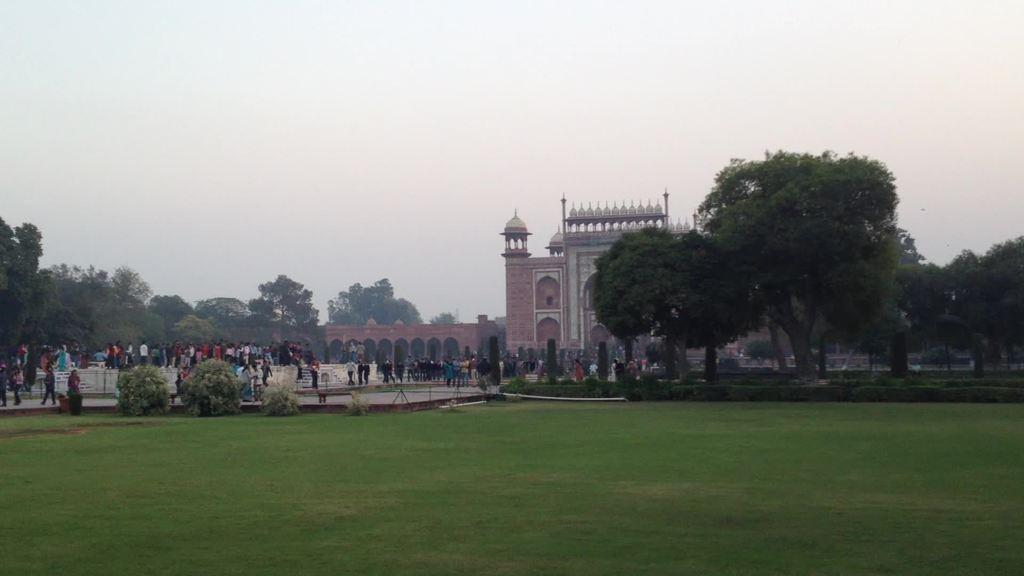What type of vegetation is present on the ground in the image? There is grass on the ground in the image. What other types of vegetation can be seen in the image? There are bushes in the image. How many people are visible in the image? There are many people in the image. What type of natural feature is present in the image? There are many trees in the image. What man-made structure can be seen in the image? There is a monument in the image. What is visible in the background of the image? The sky is visible in the background of the image. What is the condition of the nation in the image? There is no reference to a nation or its condition in the image; it primarily features vegetation, people, and a monument. 